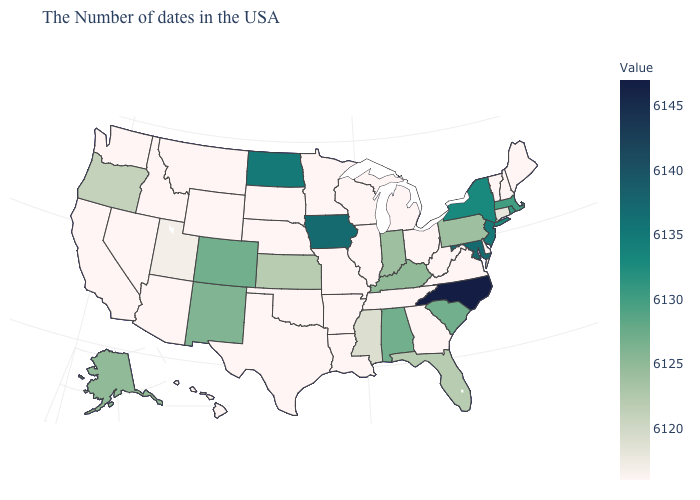Which states have the lowest value in the MidWest?
Write a very short answer. Ohio, Michigan, Wisconsin, Illinois, Missouri, Minnesota, Nebraska, South Dakota. Which states hav the highest value in the Northeast?
Quick response, please. New Jersey. Among the states that border New Jersey , which have the highest value?
Be succinct. New York. Does Rhode Island have the lowest value in the USA?
Answer briefly. No. Which states have the highest value in the USA?
Concise answer only. North Carolina. 